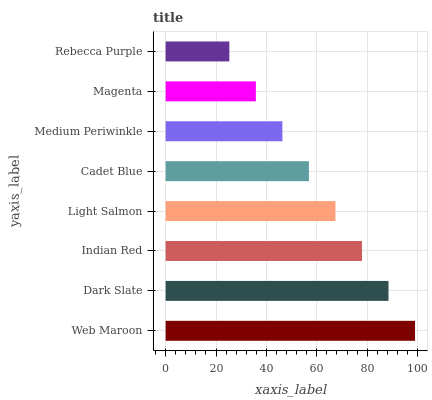Is Rebecca Purple the minimum?
Answer yes or no. Yes. Is Web Maroon the maximum?
Answer yes or no. Yes. Is Dark Slate the minimum?
Answer yes or no. No. Is Dark Slate the maximum?
Answer yes or no. No. Is Web Maroon greater than Dark Slate?
Answer yes or no. Yes. Is Dark Slate less than Web Maroon?
Answer yes or no. Yes. Is Dark Slate greater than Web Maroon?
Answer yes or no. No. Is Web Maroon less than Dark Slate?
Answer yes or no. No. Is Light Salmon the high median?
Answer yes or no. Yes. Is Cadet Blue the low median?
Answer yes or no. Yes. Is Cadet Blue the high median?
Answer yes or no. No. Is Light Salmon the low median?
Answer yes or no. No. 